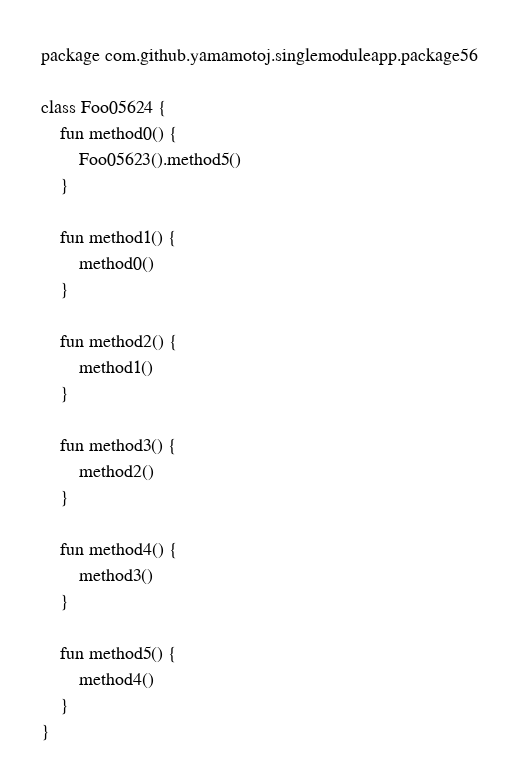<code> <loc_0><loc_0><loc_500><loc_500><_Kotlin_>package com.github.yamamotoj.singlemoduleapp.package56

class Foo05624 {
    fun method0() {
        Foo05623().method5()
    }

    fun method1() {
        method0()
    }

    fun method2() {
        method1()
    }

    fun method3() {
        method2()
    }

    fun method4() {
        method3()
    }

    fun method5() {
        method4()
    }
}
</code> 